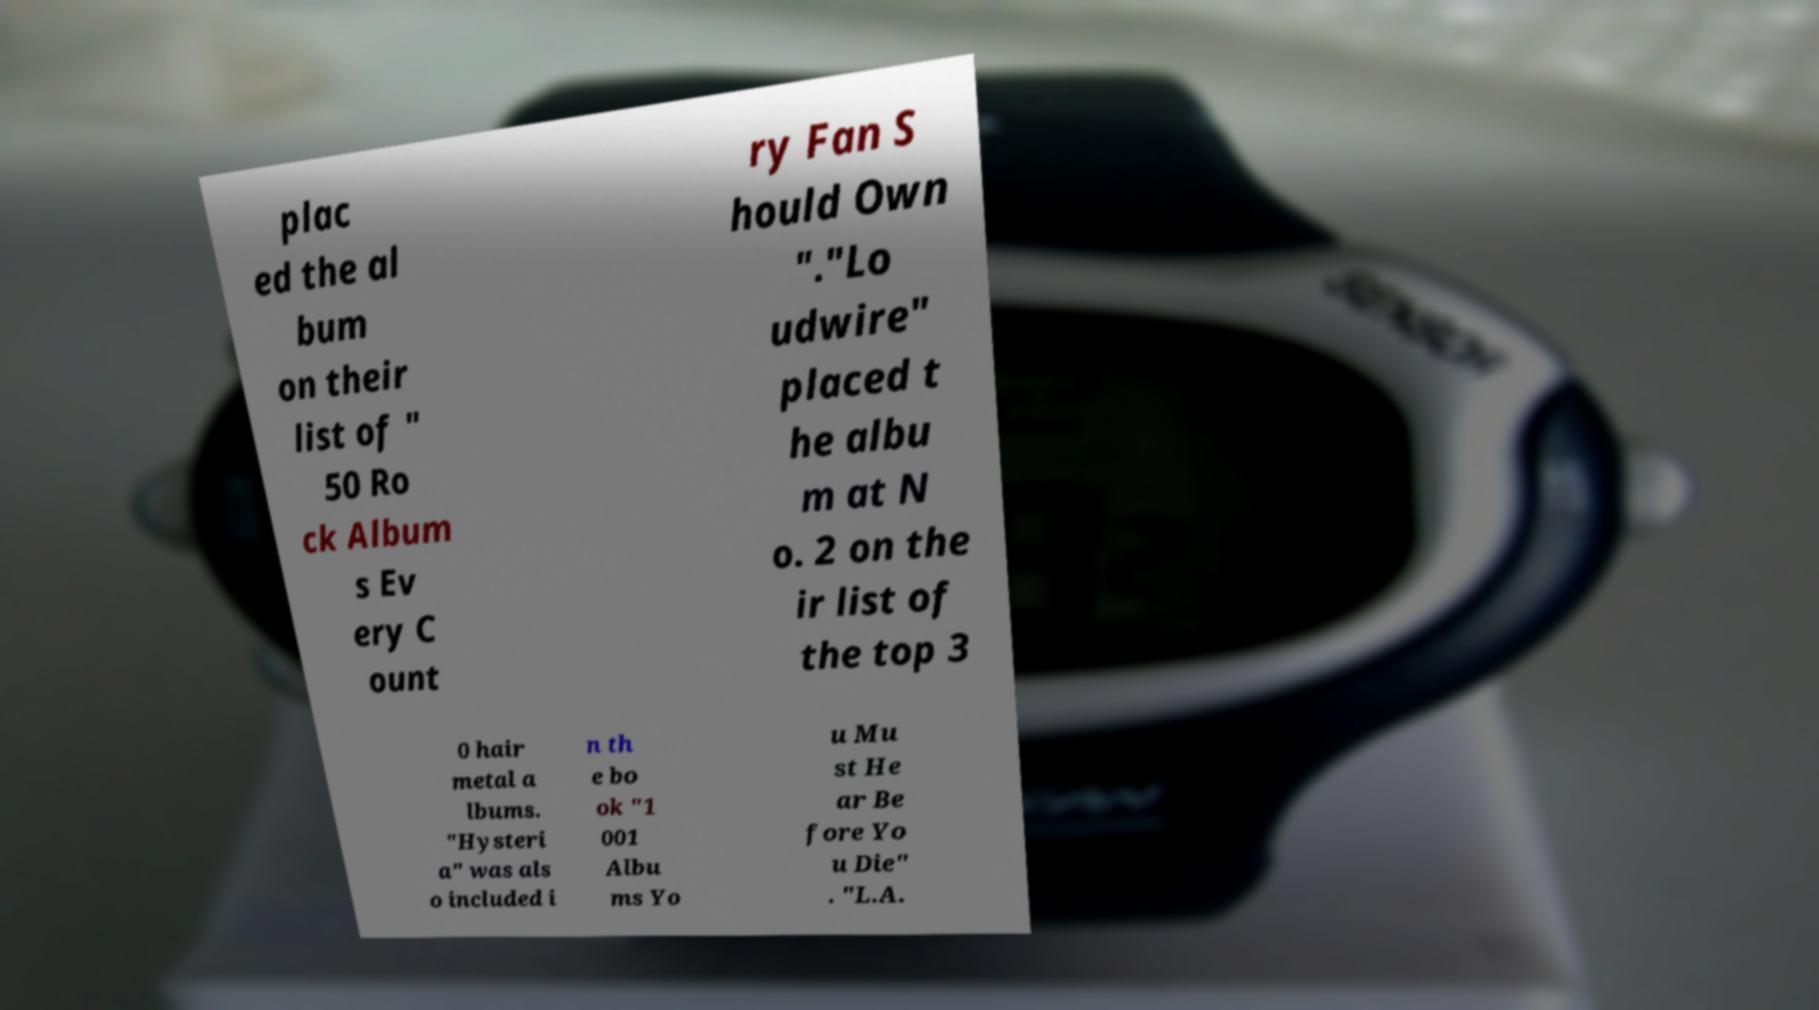Can you accurately transcribe the text from the provided image for me? plac ed the al bum on their list of " 50 Ro ck Album s Ev ery C ount ry Fan S hould Own "."Lo udwire" placed t he albu m at N o. 2 on the ir list of the top 3 0 hair metal a lbums. "Hysteri a" was als o included i n th e bo ok "1 001 Albu ms Yo u Mu st He ar Be fore Yo u Die" . "L.A. 